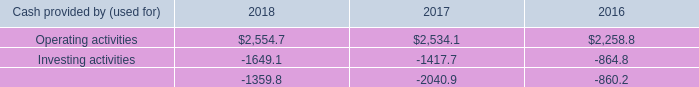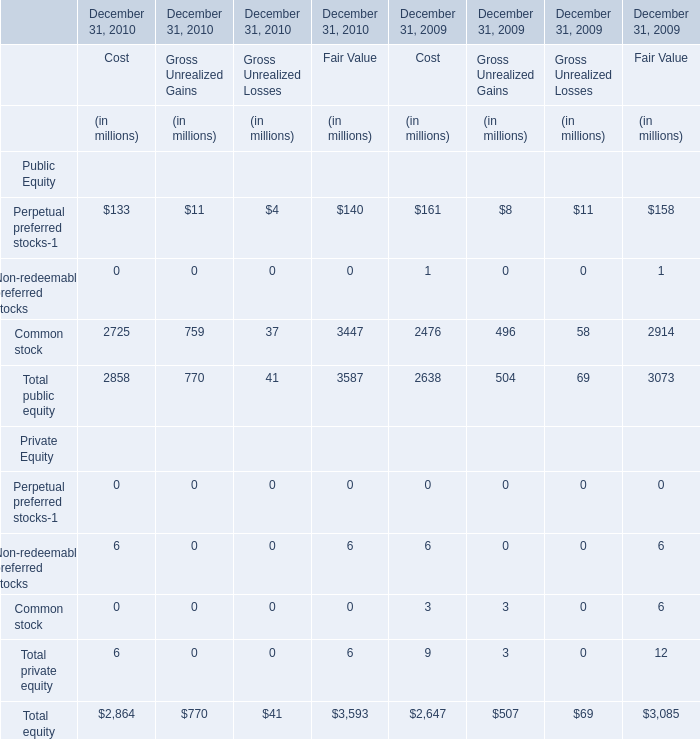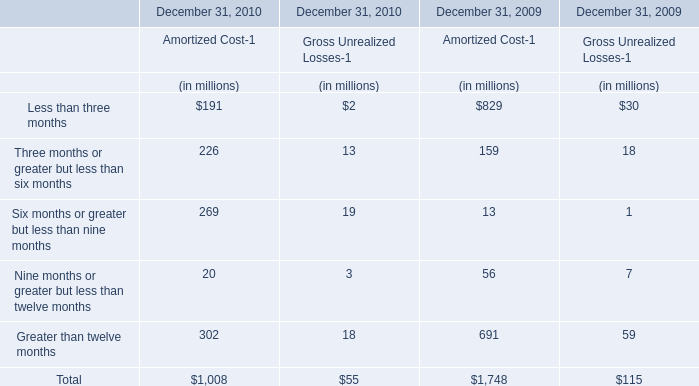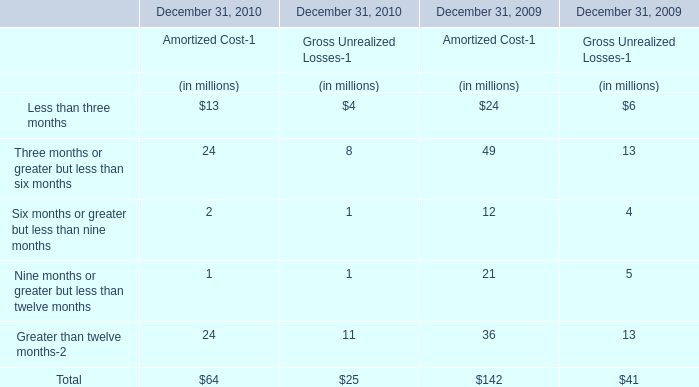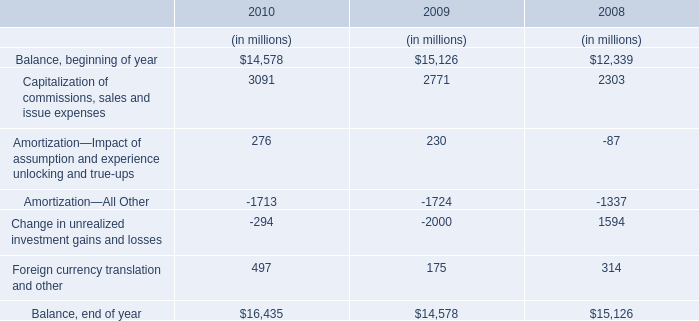What do all public equity sum up without those public equity for cost smaller than 3000, in 2010? (in million) 
Computations: (133 + 2725)
Answer: 2858.0. 